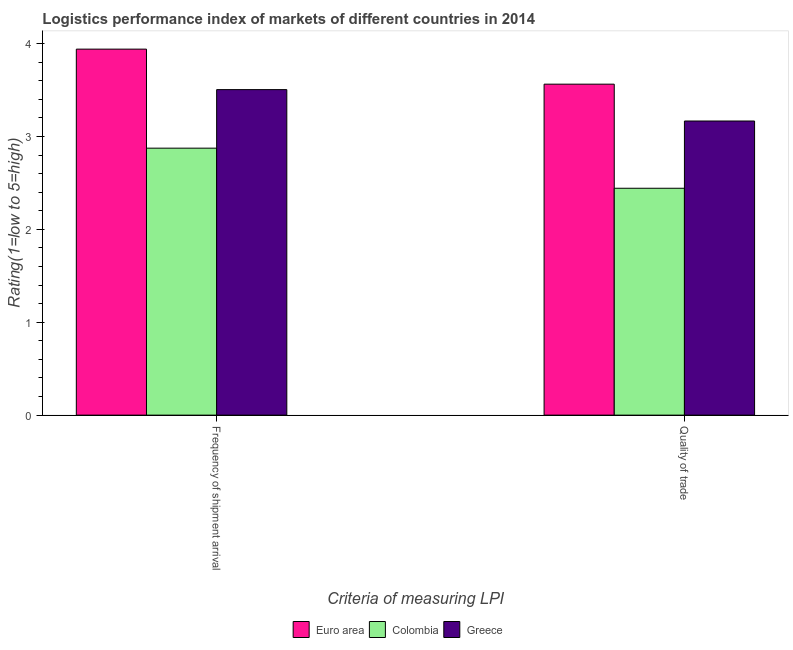How many different coloured bars are there?
Ensure brevity in your answer.  3. Are the number of bars per tick equal to the number of legend labels?
Make the answer very short. Yes. What is the label of the 2nd group of bars from the left?
Provide a short and direct response. Quality of trade. What is the lpi of frequency of shipment arrival in Greece?
Provide a succinct answer. 3.5. Across all countries, what is the maximum lpi quality of trade?
Make the answer very short. 3.56. Across all countries, what is the minimum lpi of frequency of shipment arrival?
Your answer should be compact. 2.87. In which country was the lpi quality of trade maximum?
Offer a terse response. Euro area. In which country was the lpi quality of trade minimum?
Offer a terse response. Colombia. What is the total lpi quality of trade in the graph?
Ensure brevity in your answer.  9.17. What is the difference between the lpi of frequency of shipment arrival in Greece and that in Euro area?
Offer a very short reply. -0.44. What is the difference between the lpi quality of trade in Greece and the lpi of frequency of shipment arrival in Euro area?
Your answer should be very brief. -0.77. What is the average lpi of frequency of shipment arrival per country?
Offer a very short reply. 3.44. What is the difference between the lpi quality of trade and lpi of frequency of shipment arrival in Greece?
Give a very brief answer. -0.34. In how many countries, is the lpi of frequency of shipment arrival greater than 2.6 ?
Provide a short and direct response. 3. What is the ratio of the lpi of frequency of shipment arrival in Greece to that in Colombia?
Make the answer very short. 1.22. What does the 3rd bar from the left in Quality of trade represents?
Your answer should be very brief. Greece. Are all the bars in the graph horizontal?
Ensure brevity in your answer.  No. How many countries are there in the graph?
Keep it short and to the point. 3. What is the difference between two consecutive major ticks on the Y-axis?
Ensure brevity in your answer.  1. Are the values on the major ticks of Y-axis written in scientific E-notation?
Your answer should be very brief. No. Where does the legend appear in the graph?
Your response must be concise. Bottom center. What is the title of the graph?
Keep it short and to the point. Logistics performance index of markets of different countries in 2014. Does "Nicaragua" appear as one of the legend labels in the graph?
Keep it short and to the point. No. What is the label or title of the X-axis?
Provide a short and direct response. Criteria of measuring LPI. What is the label or title of the Y-axis?
Make the answer very short. Rating(1=low to 5=high). What is the Rating(1=low to 5=high) in Euro area in Frequency of shipment arrival?
Your answer should be very brief. 3.94. What is the Rating(1=low to 5=high) in Colombia in Frequency of shipment arrival?
Provide a succinct answer. 2.87. What is the Rating(1=low to 5=high) in Greece in Frequency of shipment arrival?
Give a very brief answer. 3.5. What is the Rating(1=low to 5=high) in Euro area in Quality of trade?
Your answer should be compact. 3.56. What is the Rating(1=low to 5=high) in Colombia in Quality of trade?
Your answer should be compact. 2.44. What is the Rating(1=low to 5=high) of Greece in Quality of trade?
Provide a succinct answer. 3.17. Across all Criteria of measuring LPI, what is the maximum Rating(1=low to 5=high) in Euro area?
Offer a very short reply. 3.94. Across all Criteria of measuring LPI, what is the maximum Rating(1=low to 5=high) in Colombia?
Your answer should be compact. 2.87. Across all Criteria of measuring LPI, what is the maximum Rating(1=low to 5=high) of Greece?
Make the answer very short. 3.5. Across all Criteria of measuring LPI, what is the minimum Rating(1=low to 5=high) of Euro area?
Offer a very short reply. 3.56. Across all Criteria of measuring LPI, what is the minimum Rating(1=low to 5=high) in Colombia?
Offer a very short reply. 2.44. Across all Criteria of measuring LPI, what is the minimum Rating(1=low to 5=high) in Greece?
Provide a succinct answer. 3.17. What is the total Rating(1=low to 5=high) in Euro area in the graph?
Ensure brevity in your answer.  7.5. What is the total Rating(1=low to 5=high) in Colombia in the graph?
Offer a very short reply. 5.32. What is the total Rating(1=low to 5=high) in Greece in the graph?
Your response must be concise. 6.67. What is the difference between the Rating(1=low to 5=high) in Euro area in Frequency of shipment arrival and that in Quality of trade?
Offer a terse response. 0.38. What is the difference between the Rating(1=low to 5=high) of Colombia in Frequency of shipment arrival and that in Quality of trade?
Ensure brevity in your answer.  0.43. What is the difference between the Rating(1=low to 5=high) of Greece in Frequency of shipment arrival and that in Quality of trade?
Your response must be concise. 0.34. What is the difference between the Rating(1=low to 5=high) of Euro area in Frequency of shipment arrival and the Rating(1=low to 5=high) of Colombia in Quality of trade?
Offer a terse response. 1.5. What is the difference between the Rating(1=low to 5=high) of Euro area in Frequency of shipment arrival and the Rating(1=low to 5=high) of Greece in Quality of trade?
Provide a short and direct response. 0.77. What is the difference between the Rating(1=low to 5=high) of Colombia in Frequency of shipment arrival and the Rating(1=low to 5=high) of Greece in Quality of trade?
Offer a terse response. -0.29. What is the average Rating(1=low to 5=high) of Euro area per Criteria of measuring LPI?
Provide a short and direct response. 3.75. What is the average Rating(1=low to 5=high) of Colombia per Criteria of measuring LPI?
Your answer should be compact. 2.66. What is the average Rating(1=low to 5=high) of Greece per Criteria of measuring LPI?
Offer a terse response. 3.34. What is the difference between the Rating(1=low to 5=high) in Euro area and Rating(1=low to 5=high) in Colombia in Frequency of shipment arrival?
Ensure brevity in your answer.  1.07. What is the difference between the Rating(1=low to 5=high) in Euro area and Rating(1=low to 5=high) in Greece in Frequency of shipment arrival?
Offer a very short reply. 0.44. What is the difference between the Rating(1=low to 5=high) of Colombia and Rating(1=low to 5=high) of Greece in Frequency of shipment arrival?
Offer a very short reply. -0.63. What is the difference between the Rating(1=low to 5=high) in Euro area and Rating(1=low to 5=high) in Colombia in Quality of trade?
Ensure brevity in your answer.  1.12. What is the difference between the Rating(1=low to 5=high) in Euro area and Rating(1=low to 5=high) in Greece in Quality of trade?
Your answer should be compact. 0.4. What is the difference between the Rating(1=low to 5=high) of Colombia and Rating(1=low to 5=high) of Greece in Quality of trade?
Ensure brevity in your answer.  -0.72. What is the ratio of the Rating(1=low to 5=high) of Euro area in Frequency of shipment arrival to that in Quality of trade?
Make the answer very short. 1.11. What is the ratio of the Rating(1=low to 5=high) in Colombia in Frequency of shipment arrival to that in Quality of trade?
Make the answer very short. 1.18. What is the ratio of the Rating(1=low to 5=high) in Greece in Frequency of shipment arrival to that in Quality of trade?
Keep it short and to the point. 1.11. What is the difference between the highest and the second highest Rating(1=low to 5=high) of Euro area?
Your answer should be compact. 0.38. What is the difference between the highest and the second highest Rating(1=low to 5=high) in Colombia?
Keep it short and to the point. 0.43. What is the difference between the highest and the second highest Rating(1=low to 5=high) in Greece?
Offer a very short reply. 0.34. What is the difference between the highest and the lowest Rating(1=low to 5=high) in Euro area?
Offer a very short reply. 0.38. What is the difference between the highest and the lowest Rating(1=low to 5=high) of Colombia?
Make the answer very short. 0.43. What is the difference between the highest and the lowest Rating(1=low to 5=high) of Greece?
Make the answer very short. 0.34. 